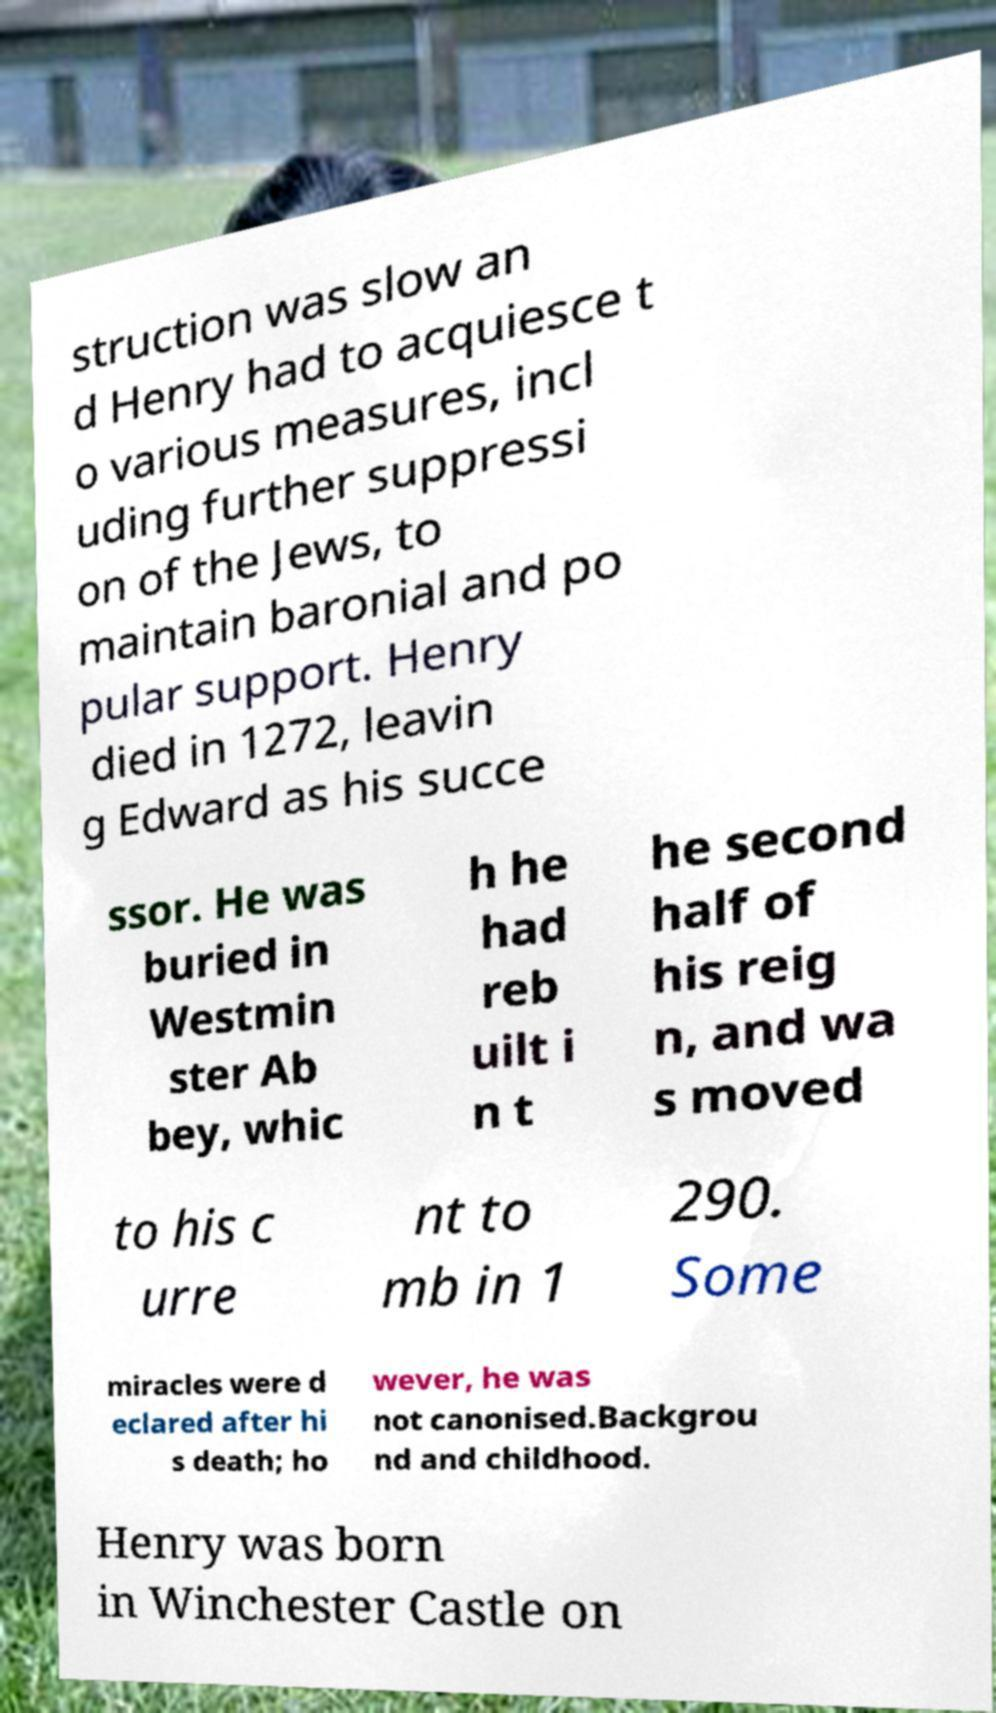Please read and relay the text visible in this image. What does it say? struction was slow an d Henry had to acquiesce t o various measures, incl uding further suppressi on of the Jews, to maintain baronial and po pular support. Henry died in 1272, leavin g Edward as his succe ssor. He was buried in Westmin ster Ab bey, whic h he had reb uilt i n t he second half of his reig n, and wa s moved to his c urre nt to mb in 1 290. Some miracles were d eclared after hi s death; ho wever, he was not canonised.Backgrou nd and childhood. Henry was born in Winchester Castle on 